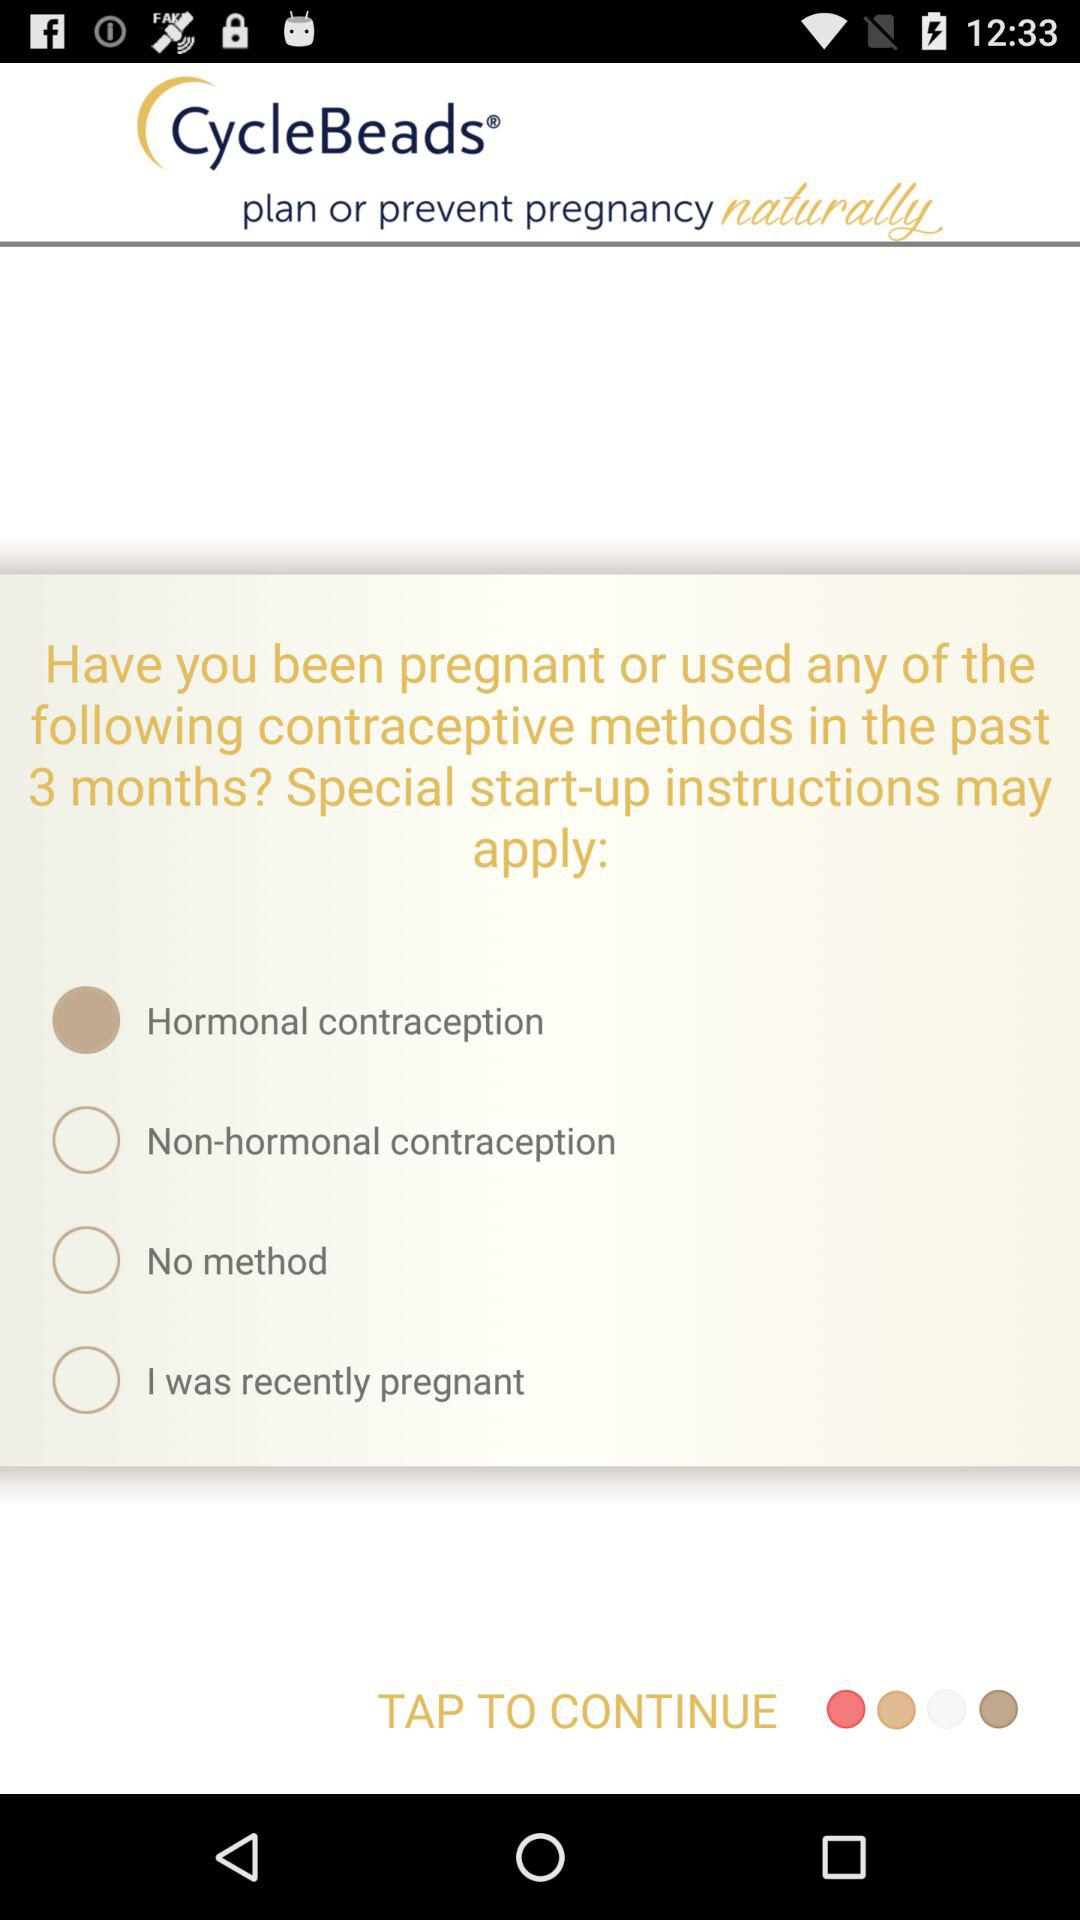Which option is selected for "Have you been pregnant or used any of the following contraceptive methods in the past 3 months? Special start-up instructions may apply:"? The selected option is "Hormonal contraception". 